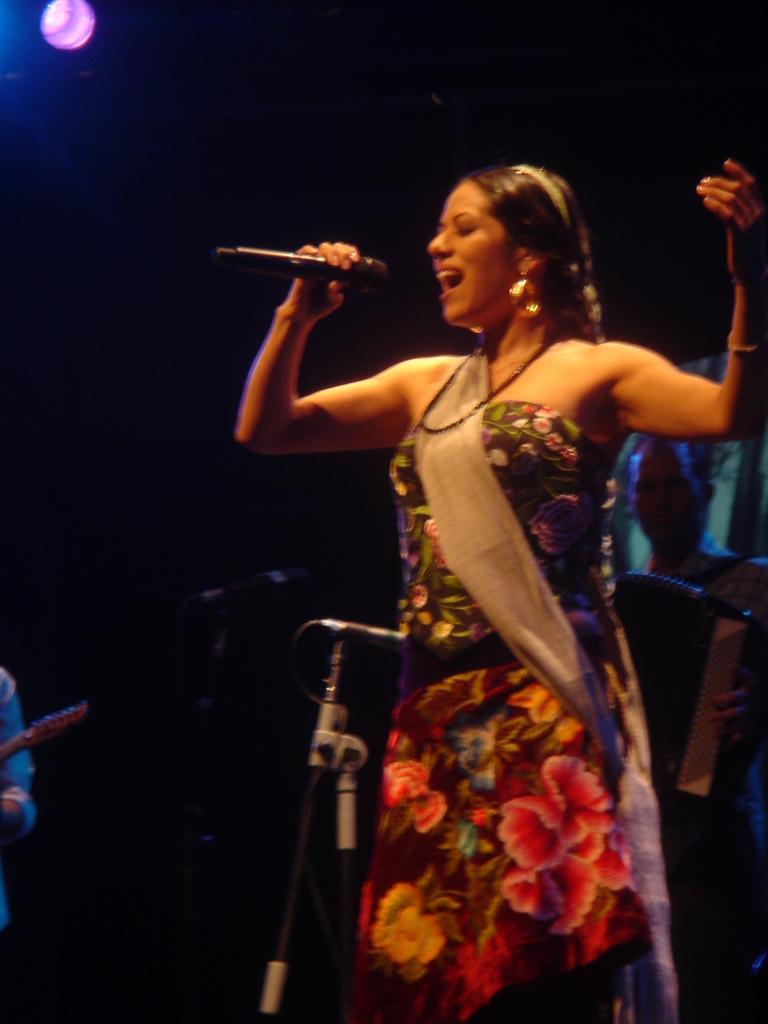How would you summarize this image in a sentence or two? In this image there is a woman holding a mike and singing. Image also consists of two mics with stands. We can also see some persons in the background. 